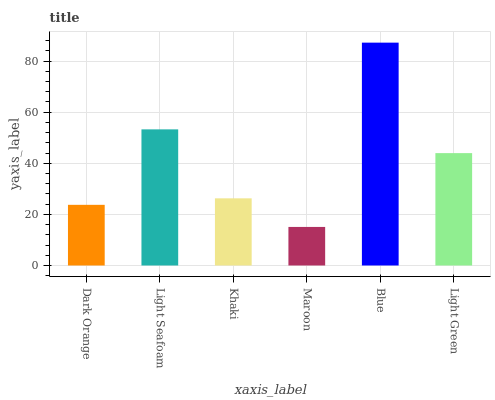Is Maroon the minimum?
Answer yes or no. Yes. Is Blue the maximum?
Answer yes or no. Yes. Is Light Seafoam the minimum?
Answer yes or no. No. Is Light Seafoam the maximum?
Answer yes or no. No. Is Light Seafoam greater than Dark Orange?
Answer yes or no. Yes. Is Dark Orange less than Light Seafoam?
Answer yes or no. Yes. Is Dark Orange greater than Light Seafoam?
Answer yes or no. No. Is Light Seafoam less than Dark Orange?
Answer yes or no. No. Is Light Green the high median?
Answer yes or no. Yes. Is Khaki the low median?
Answer yes or no. Yes. Is Maroon the high median?
Answer yes or no. No. Is Light Green the low median?
Answer yes or no. No. 